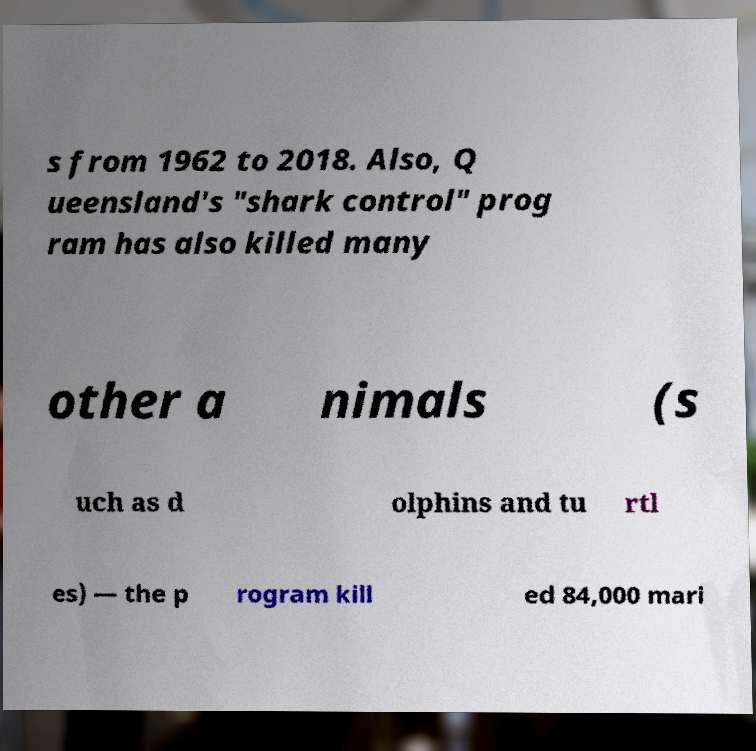Could you assist in decoding the text presented in this image and type it out clearly? s from 1962 to 2018. Also, Q ueensland's "shark control" prog ram has also killed many other a nimals (s uch as d olphins and tu rtl es) — the p rogram kill ed 84,000 mari 